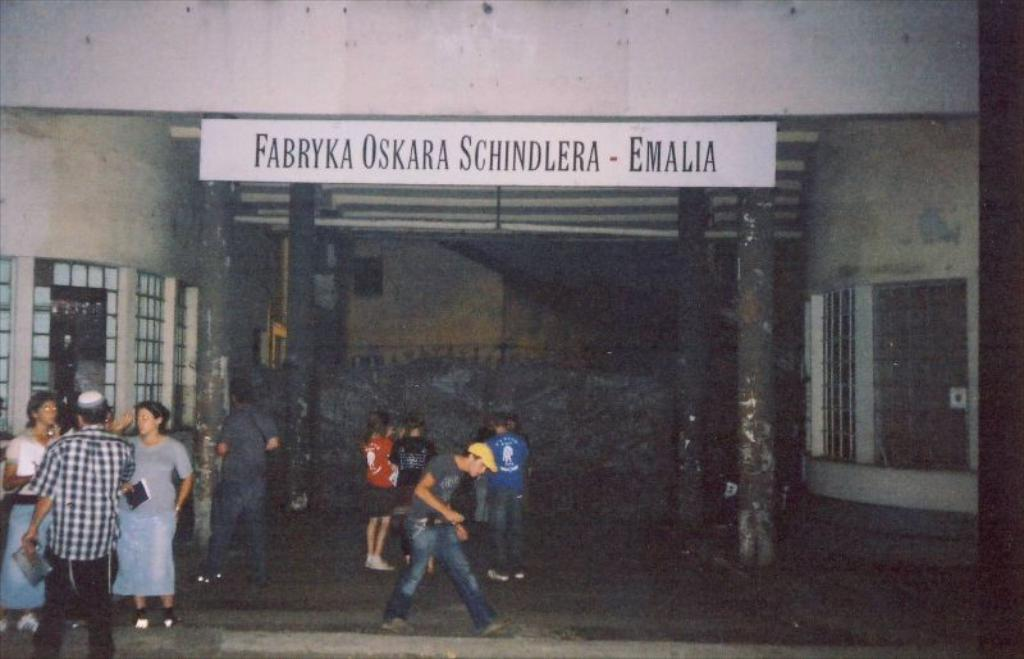What is the main structure visible in the image? There is a building in the image. What are the people in front of the building doing? The people are standing and walking in front of the building. Can you describe the board with text hanging from the wall of the building? Yes, there is a board with text hanging from the wall of the building. How many toes can be seen on the people walking in front of the building? There is no way to determine the number of toes on the people walking in front of the building from the image. 